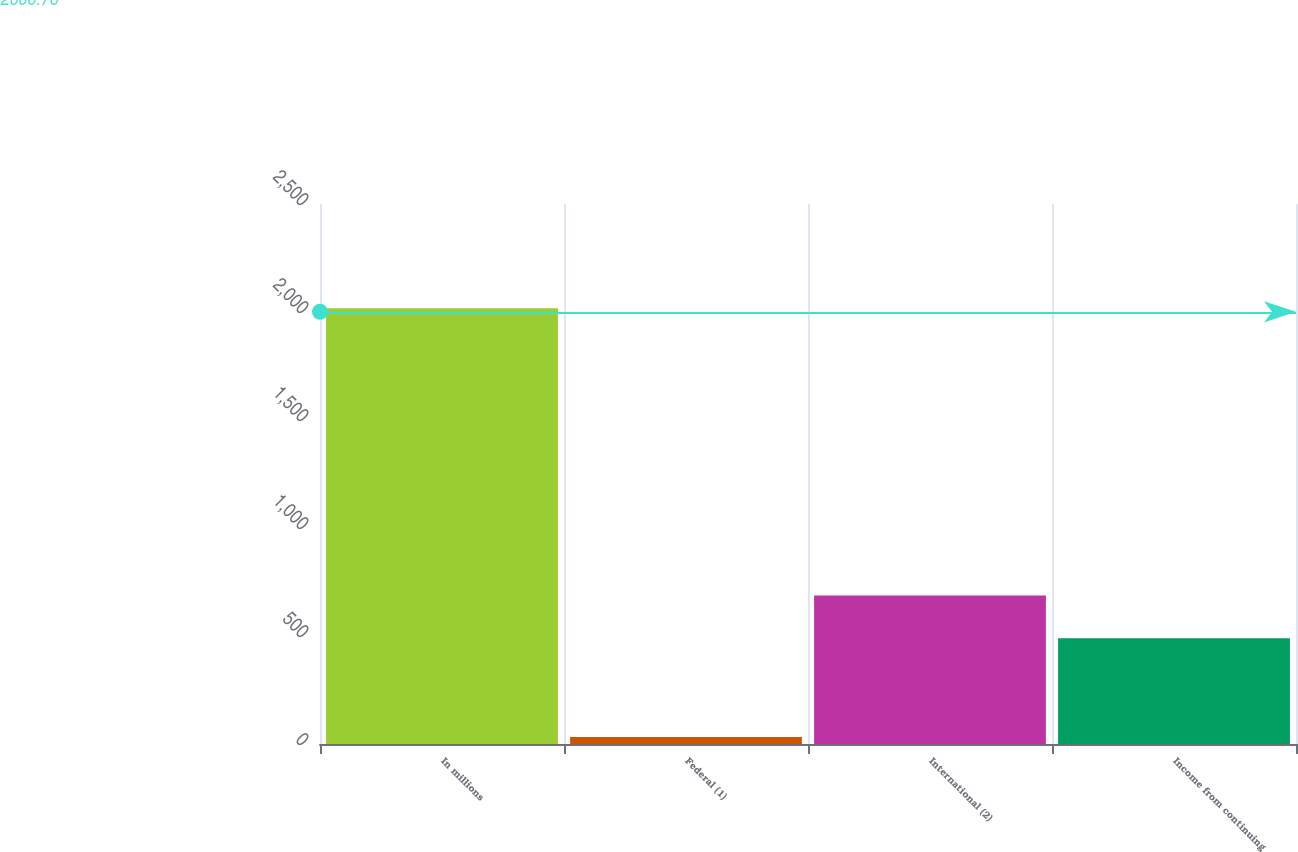Convert chart to OTSL. <chart><loc_0><loc_0><loc_500><loc_500><bar_chart><fcel>In millions<fcel>Federal (1)<fcel>International (2)<fcel>Income from continuing<nl><fcel>2017<fcel>32.8<fcel>687.62<fcel>489.2<nl></chart> 